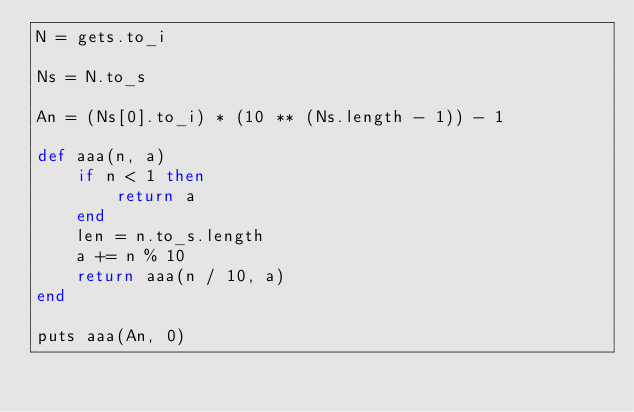Convert code to text. <code><loc_0><loc_0><loc_500><loc_500><_Ruby_>N = gets.to_i

Ns = N.to_s

An = (Ns[0].to_i) * (10 ** (Ns.length - 1)) - 1

def aaa(n, a)
    if n < 1 then
        return a
    end
    len = n.to_s.length
    a += n % 10
    return aaa(n / 10, a)
end

puts aaa(An, 0)</code> 